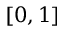Convert formula to latex. <formula><loc_0><loc_0><loc_500><loc_500>[ 0 , 1 ]</formula> 